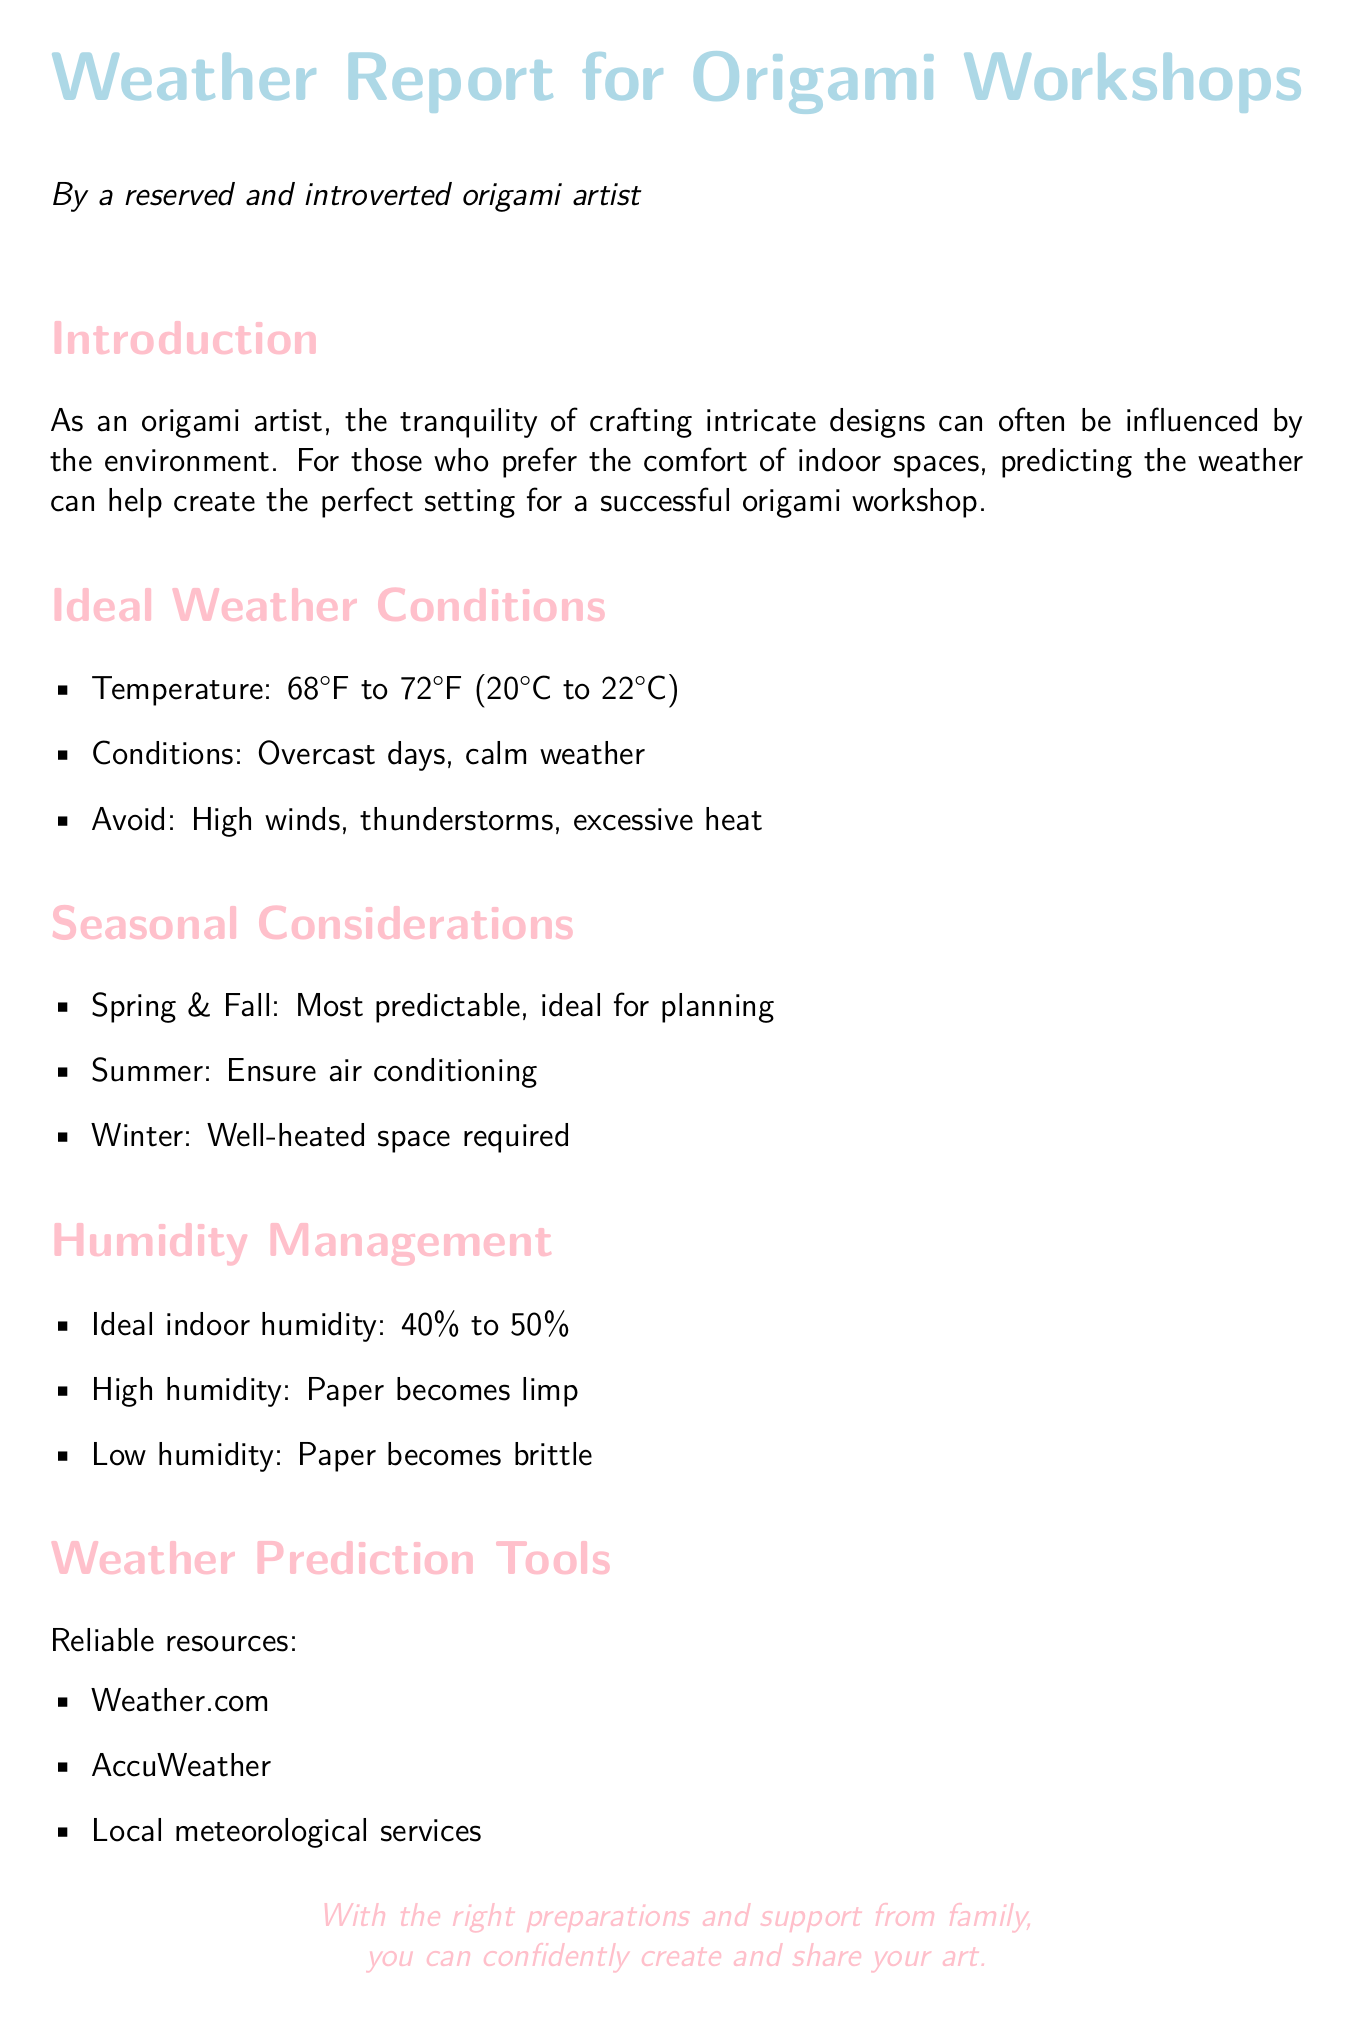What is the ideal temperature range for crafting? The document states that the ideal temperature range for crafting is between 68°F to 72°F.
Answer: 68°F to 72°F What type of weather is best for an origami workshop? According to the report, calm weather and overcast days are ideal for origami workshops.
Answer: Overcast days, calm weather What humidity percentage is considered ideal indoors? The ideal indoor humidity is stated to be between 40% to 50%.
Answer: 40% to 50% Which seasons are most predictable for origami planning? The report mentions that spring and fall are the most predictable seasons for planning origami workshops.
Answer: Spring & Fall What should be avoided when planning an origami workshop? High winds, thunderstorms, and excessive heat should be avoided according to the report.
Answer: High winds, thunderstorms, excessive heat What is necessary for summer crafting? The document indicates that air conditioning is necessary for crafting in the summer.
Answer: Air conditioning What happens to paper in high humidity? High humidity causes the paper to become limp, according to the report.
Answer: Limp Name a reliable weather prediction resource mentioned. The document lists Weather.com as a reliable weather prediction resource.
Answer: Weather.com 